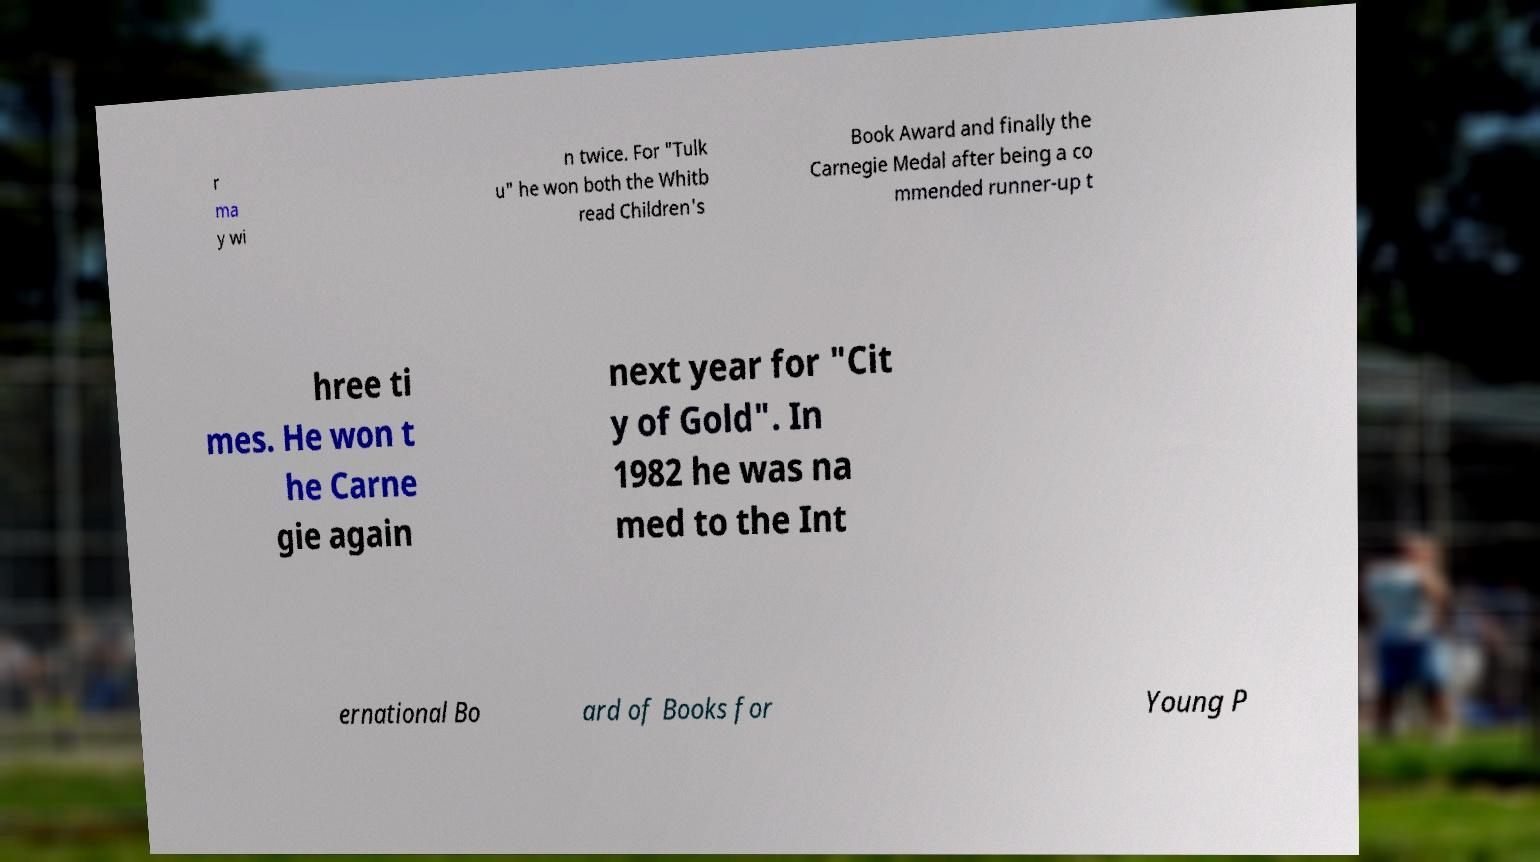What messages or text are displayed in this image? I need them in a readable, typed format. r ma y wi n twice. For "Tulk u" he won both the Whitb read Children's Book Award and finally the Carnegie Medal after being a co mmended runner-up t hree ti mes. He won t he Carne gie again next year for "Cit y of Gold". In 1982 he was na med to the Int ernational Bo ard of Books for Young P 